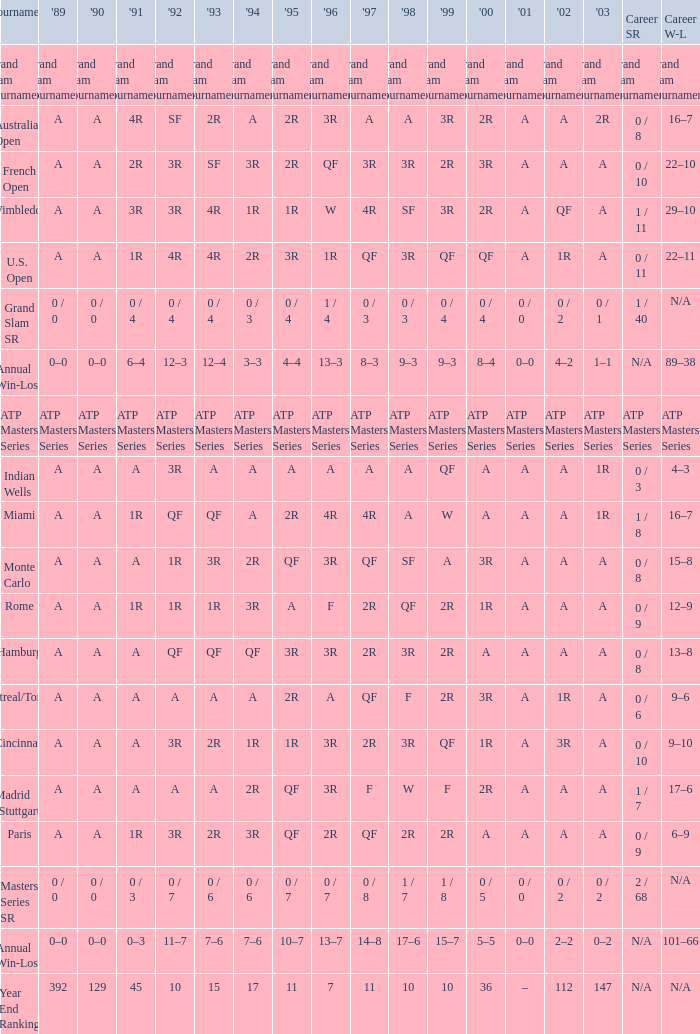What is the value in 1997 when the value in 1989 is A, 1995 is QF, 1996 is 3R and the career SR is 0 / 8? QF. 